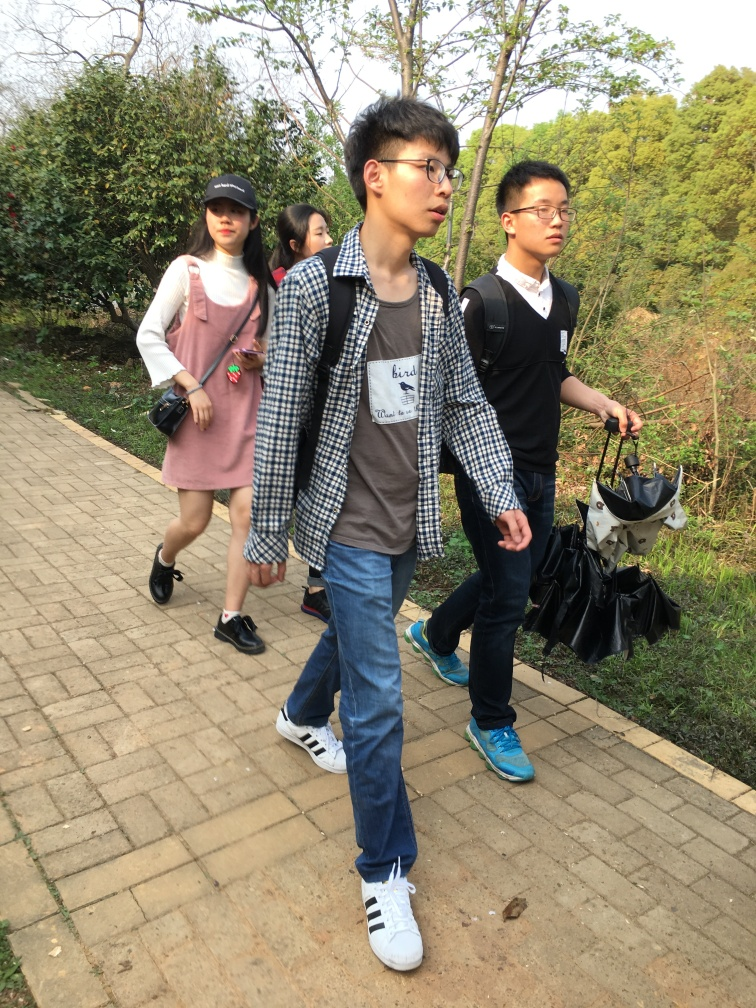Does this photo seem to capture a casual outing or an event of some significance? The photo seems to capture a casual outing. The relaxed expressions, casual walking posture, and the general attire suggest that these individuals are likely enjoying a leisurely stroll rather than attending any formal event or significant occasion. 